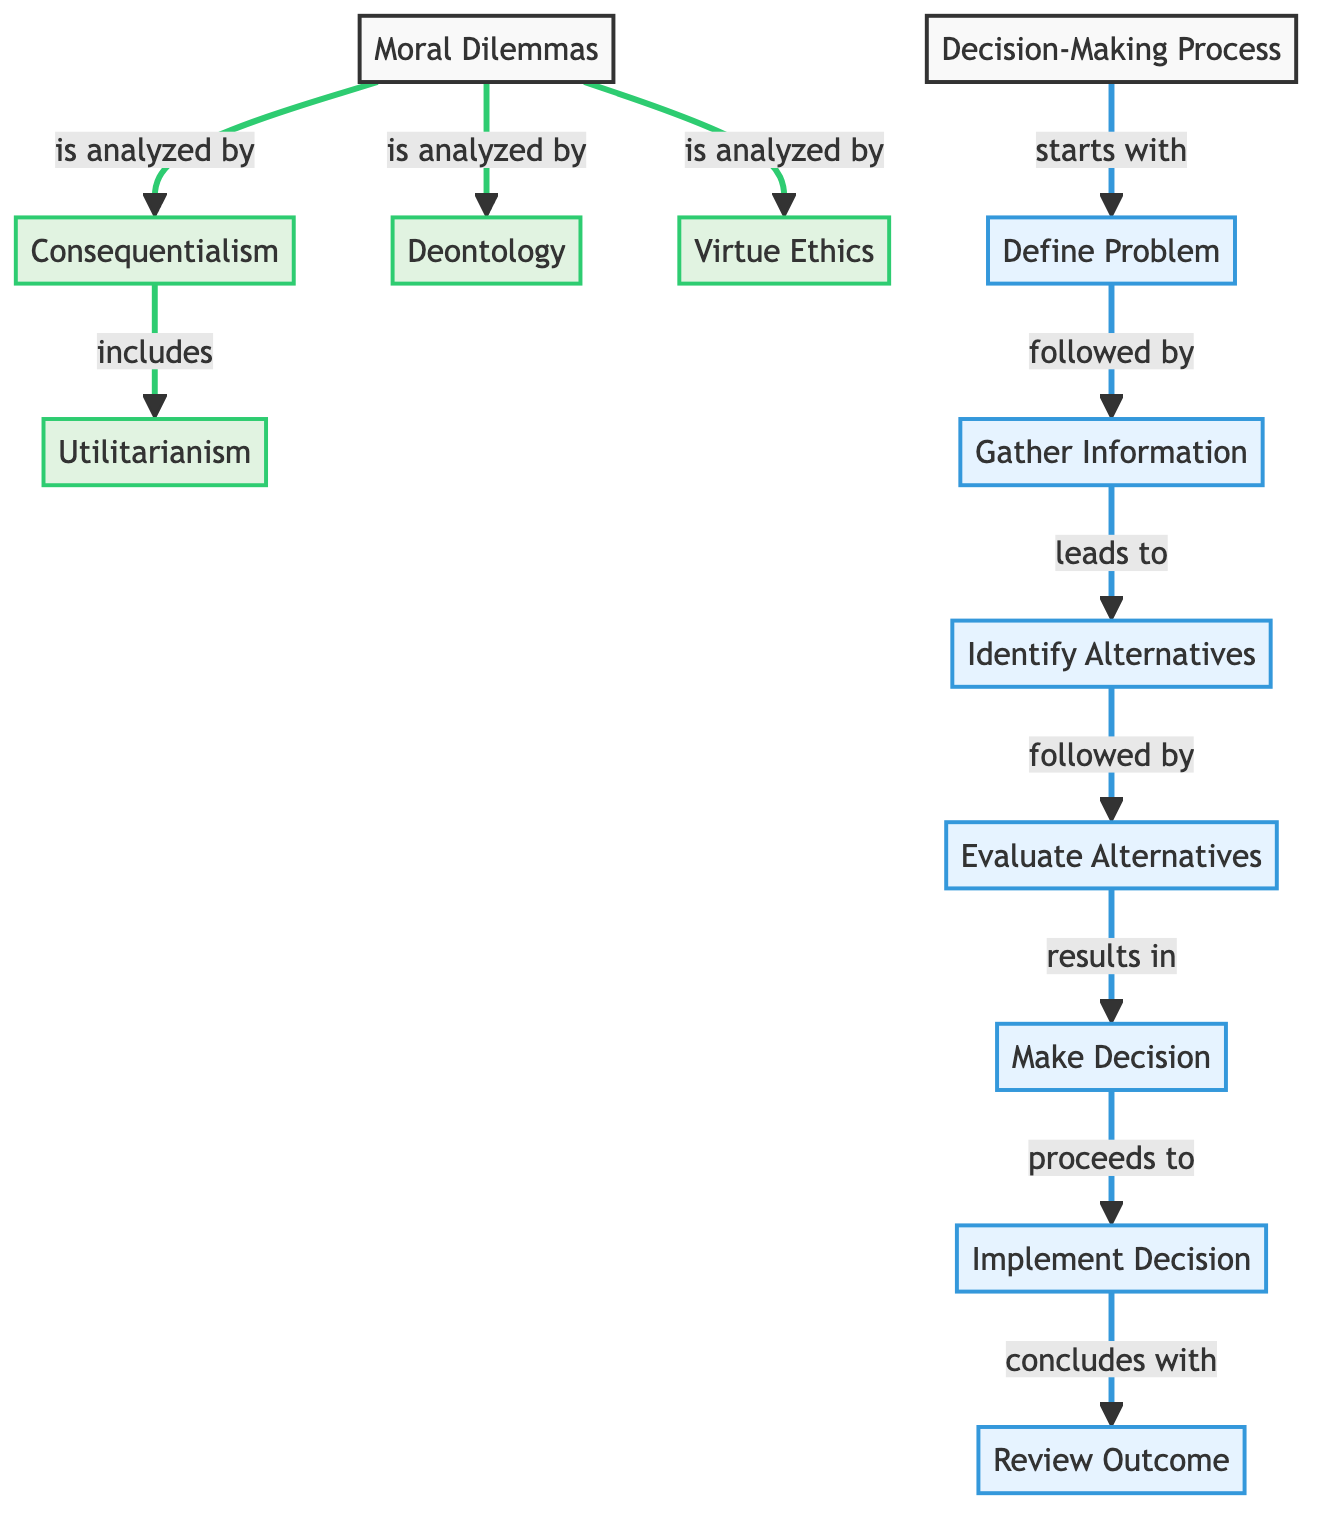What are the main ethical theories analyzed in moral dilemmas? The diagram shows three main ethical theories: Consequentialism, Deontology, and Virtue Ethics, all branching from the central node 'Moral Dilemmas'.
Answer: Consequentialism, Deontology, Virtue Ethics How many nodes represent the decision-making process? In the diagram, the decision-making process has a total of seven nodes: Define Problem, Gather Information, Identify Alternatives, Evaluate Alternatives, Make Decision, Implement Decision, and Review Outcome.
Answer: 7 Which step follows 'Identify Alternatives'? The diagram indicates that 'Evaluate Alternatives' is the step that comes after 'Identify Alternatives' in the decision-making process.
Answer: Evaluate Alternatives What is the first step in the decision-making process? According to the diagram, the first step outlined in the decision-making process is 'Define Problem'.
Answer: Define Problem How many ethical theories are connected directly to 'Moral Dilemmas'? There are three ethical theories connected directly to 'Moral Dilemmas' in the diagram: Consequentialism, Deontology, and Virtue Ethics, making the total breadth equal to three.
Answer: 3 What is the final step in the decision-making process? The final step presented in the decision-making process is 'Review Outcome', as shown in the sequence of the steps.
Answer: Review Outcome Which ethical theory is a subset of Consequentialism? The diagram indicates that Utilitarianism is a subset or component of Consequentialism, as it falls under the branch labeled 'Consequentialism'.
Answer: Utilitarianism What is the relationship between 'Evaluate Alternatives' and 'Make Decision'? The relationship between 'Evaluate Alternatives' and 'Make Decision' is sequential; 'Evaluate Alternatives' leads directly to 'Make Decision', illustrating the flow of the decision-making process.
Answer: 'Evaluate Alternatives' leads to 'Make Decision' What colors represent the ethical theories in the diagram? The ethical theories in the diagram are represented with a green shade, as indicated by the class definition associated with those nodes.
Answer: Green 